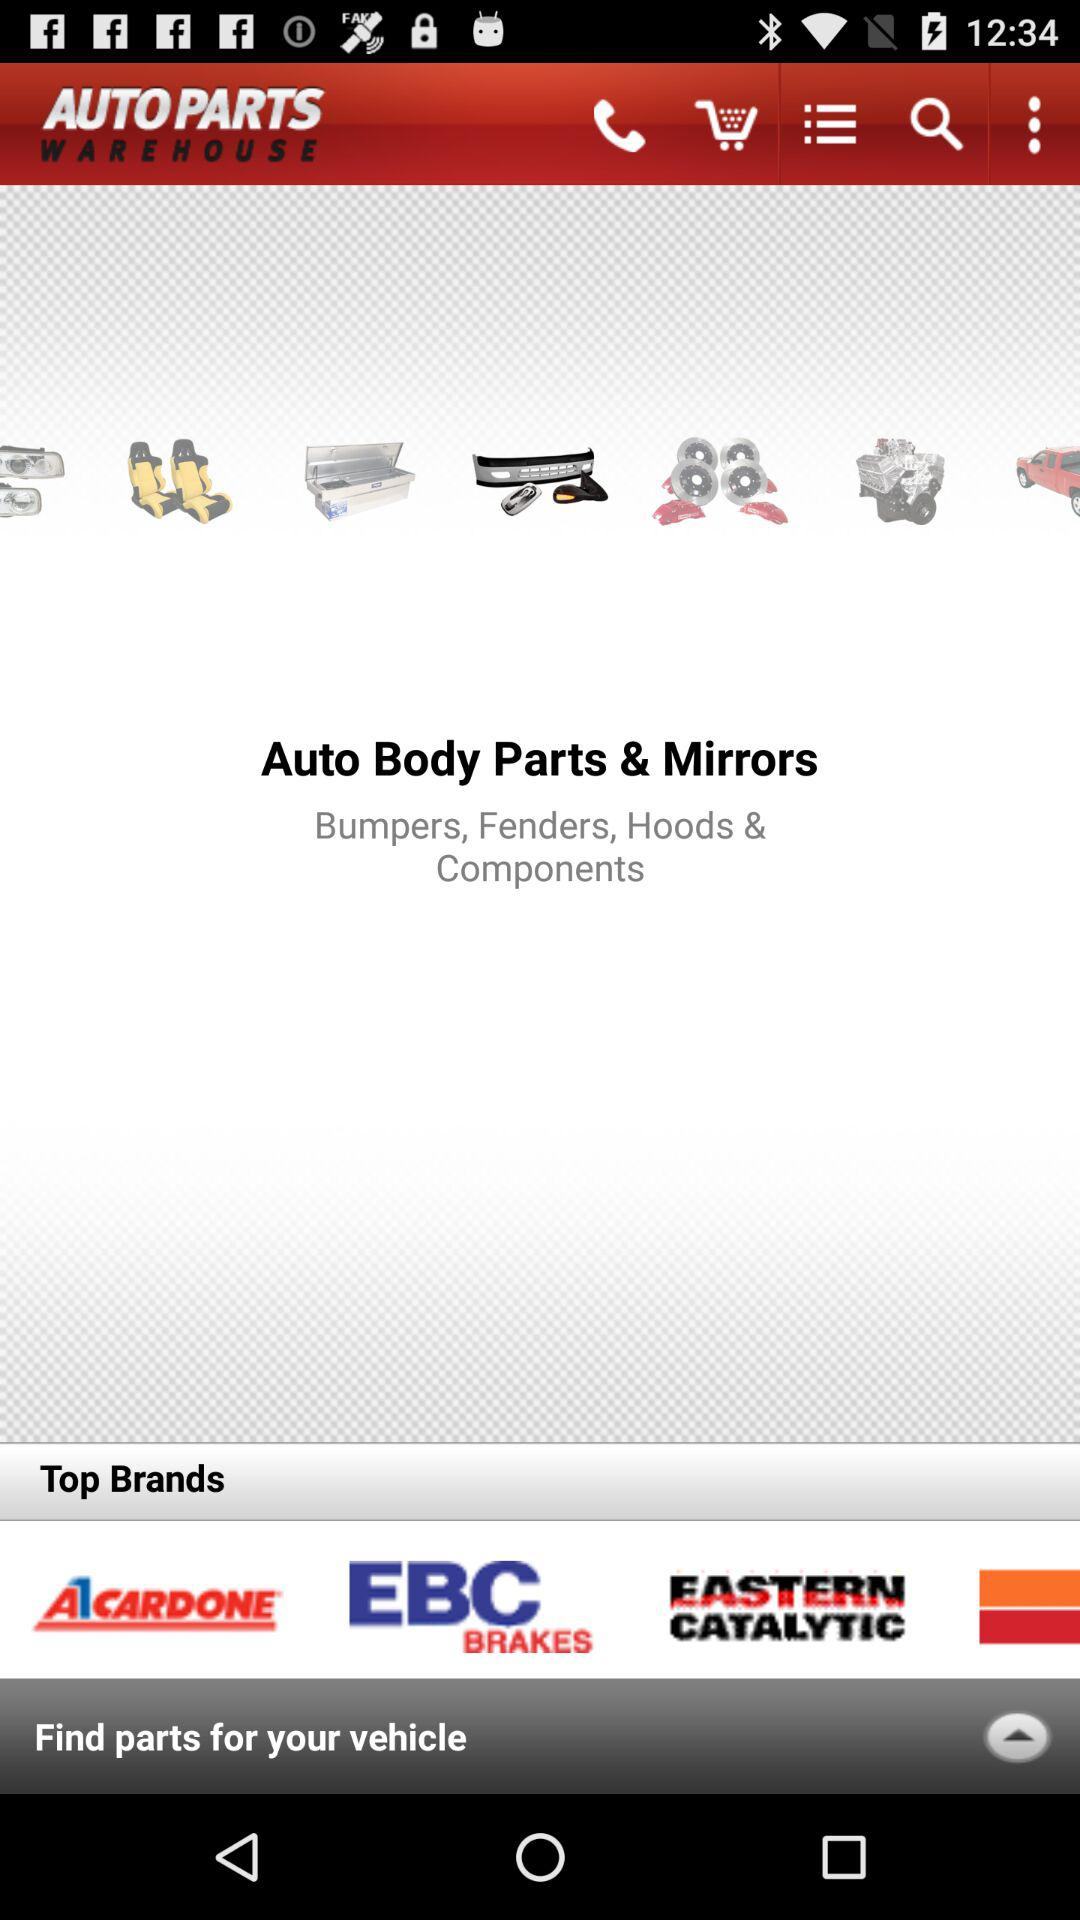What is the name of the application? The name of the application is "AUTO PARTS WAREHOUSE". 